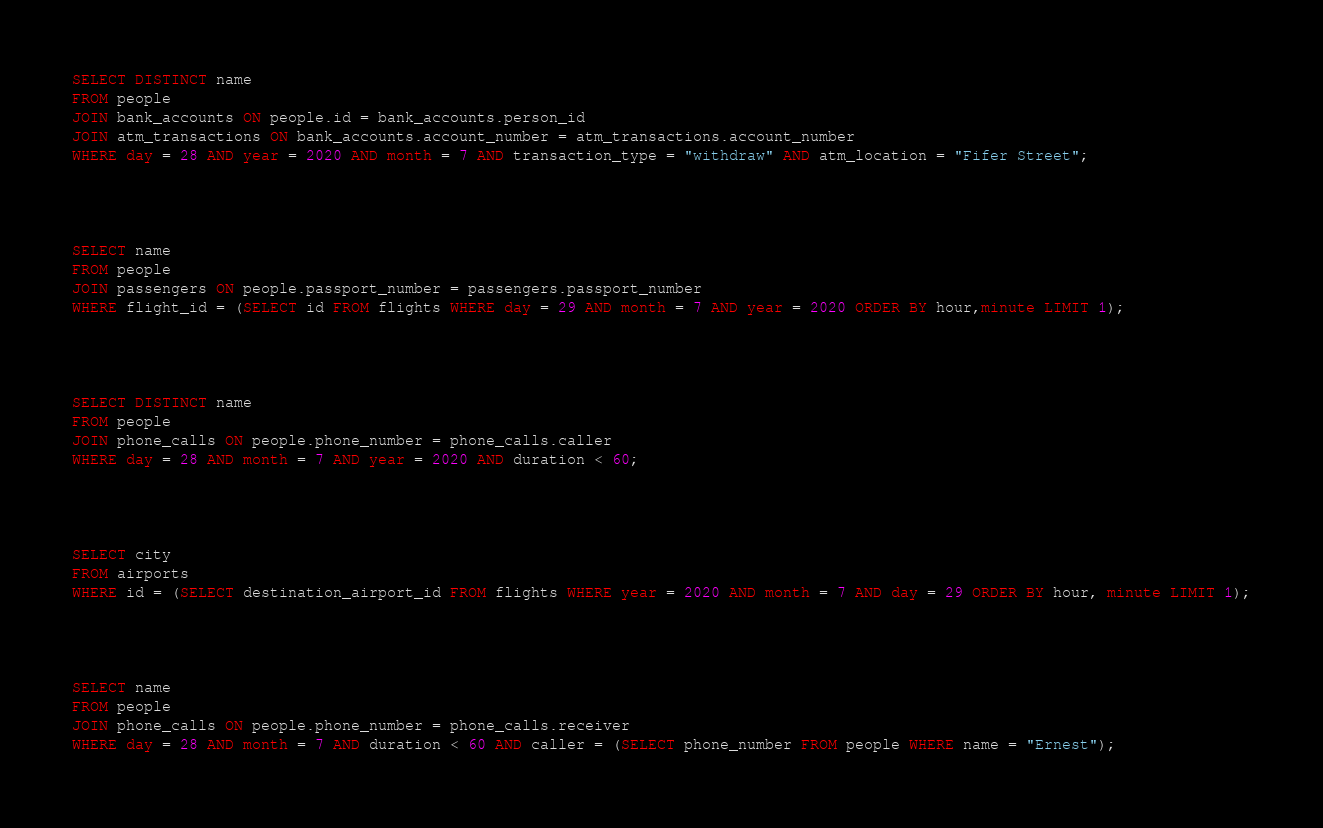<code> <loc_0><loc_0><loc_500><loc_500><_SQL_>SELECT DISTINCT name
FROM people
JOIN bank_accounts ON people.id = bank_accounts.person_id
JOIN atm_transactions ON bank_accounts.account_number = atm_transactions.account_number
WHERE day = 28 AND year = 2020 AND month = 7 AND transaction_type = "withdraw" AND atm_location = "Fifer Street";




SELECT name
FROM people
JOIN passengers ON people.passport_number = passengers.passport_number
WHERE flight_id = (SELECT id FROM flights WHERE day = 29 AND month = 7 AND year = 2020 ORDER BY hour,minute LIMIT 1);




SELECT DISTINCT name
FROM people
JOIN phone_calls ON people.phone_number = phone_calls.caller
WHERE day = 28 AND month = 7 AND year = 2020 AND duration < 60;




SELECT city
FROM airports
WHERE id = (SELECT destination_airport_id FROM flights WHERE year = 2020 AND month = 7 AND day = 29 ORDER BY hour, minute LIMIT 1);




SELECT name
FROM people
JOIN phone_calls ON people.phone_number = phone_calls.receiver
WHERE day = 28 AND month = 7 AND duration < 60 AND caller = (SELECT phone_number FROM people WHERE name = "Ernest");
</code> 